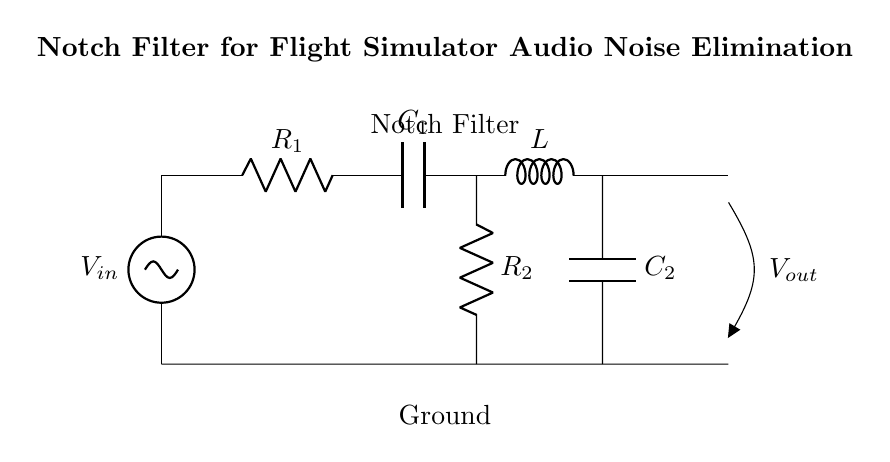What components are in the notch filter circuit? The circuit features a voltage source, two resistors, two capacitors, and an inductor, which together form the notch filter for noise elimination.
Answer: voltage source, resistors, capacitors, inductor What does Vout represent in the circuit? Vout represents the output voltage of the circuit, which is taken across the components in the circuit that filter the incoming noise.
Answer: output voltage Which component provides inductance? The component providing inductance is labeled as L in the circuit diagram, which is essential for creating the notch response.
Answer: L How many resistors are present in the circuit? The circuit has two resistors, R1 and R2, that are part of the filter design.
Answer: two What is the role of C2 in the circuit? C2, as a capacitor, works in combination with the other components to tune the filter to eliminate specific noise frequencies from the audio input.
Answer: noise elimination What is the function of the parallel RLC circuit? The parallel RLC circuit (resistor, inductor, capacitor) is responsible for creating a notch around a specific frequency, effectively filtering out noise.
Answer: notch frequency filtering 